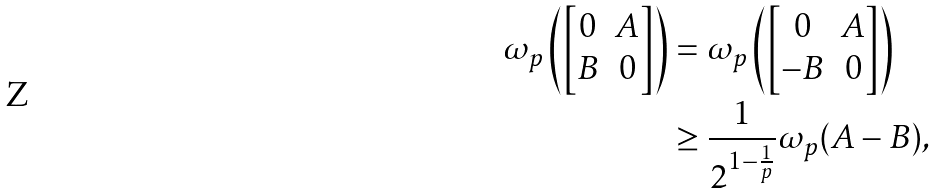<formula> <loc_0><loc_0><loc_500><loc_500>\omega _ { p } \left ( \begin{bmatrix} 0 & A \\ B & 0 \end{bmatrix} \right ) & = \omega _ { p } \left ( \begin{bmatrix} 0 & A \\ - B & 0 \end{bmatrix} \right ) \\ & \geq \frac { 1 } { 2 ^ { 1 - \frac { 1 } { p } } } \omega _ { p } ( A - B ) ,</formula> 